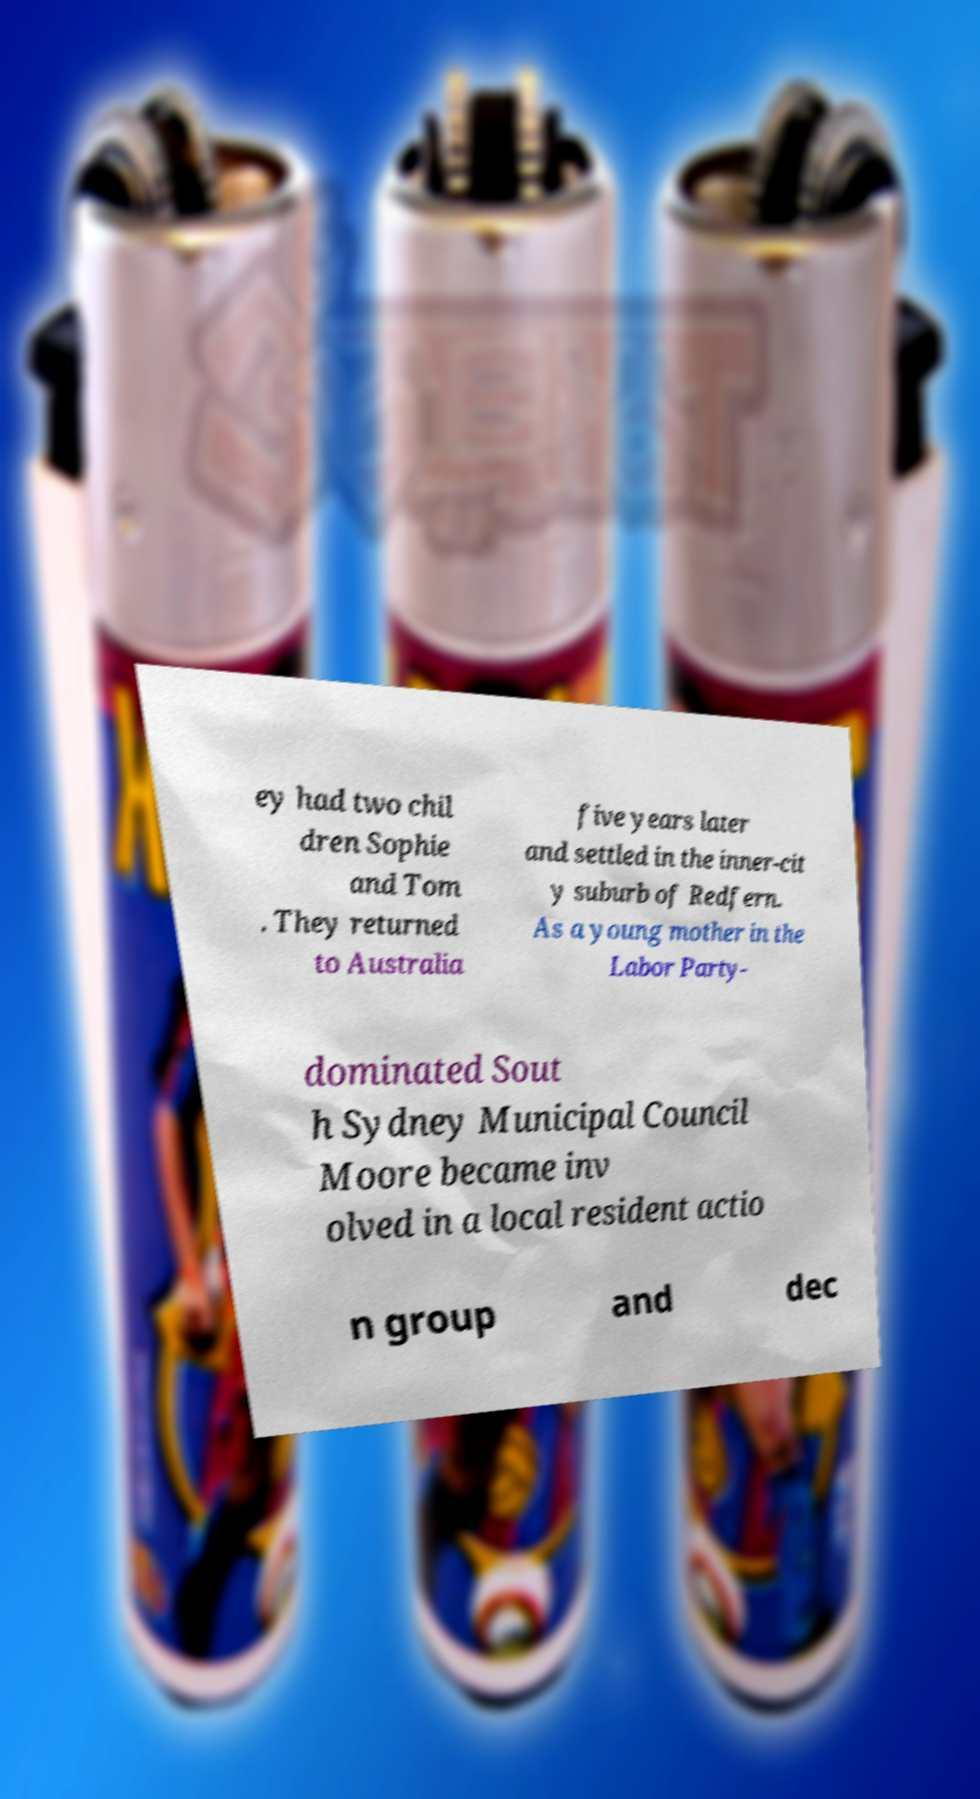For documentation purposes, I need the text within this image transcribed. Could you provide that? ey had two chil dren Sophie and Tom . They returned to Australia five years later and settled in the inner-cit y suburb of Redfern. As a young mother in the Labor Party- dominated Sout h Sydney Municipal Council Moore became inv olved in a local resident actio n group and dec 